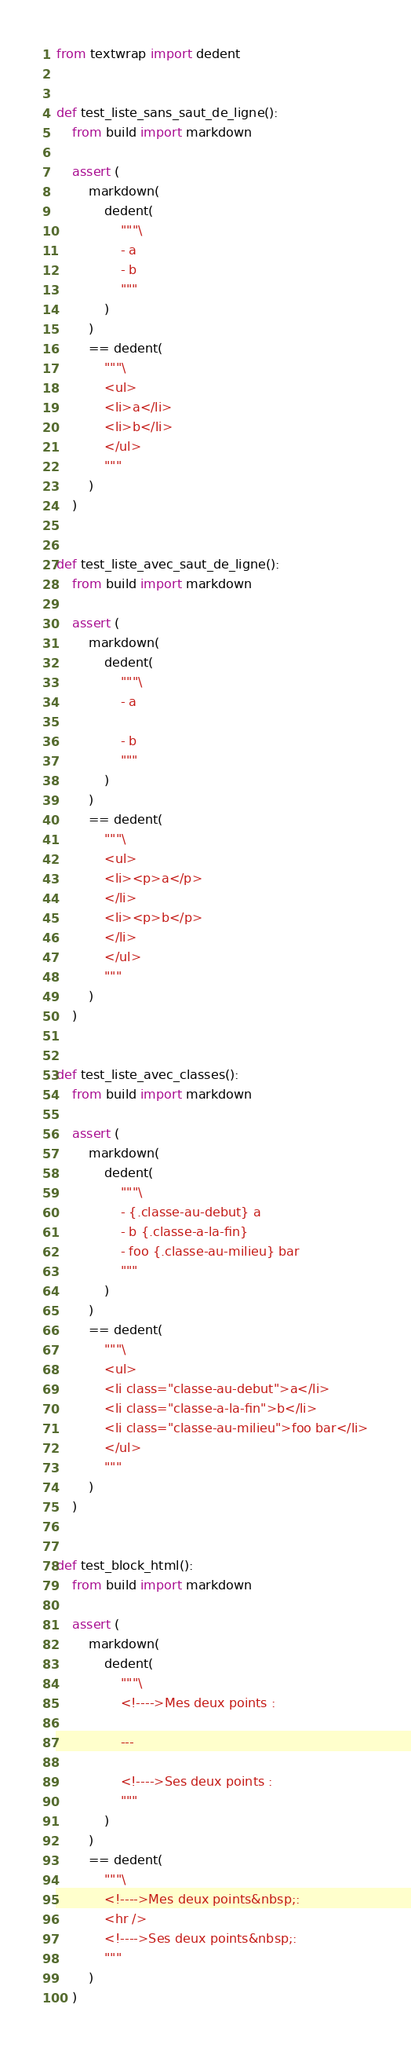<code> <loc_0><loc_0><loc_500><loc_500><_Python_>from textwrap import dedent


def test_liste_sans_saut_de_ligne():
    from build import markdown

    assert (
        markdown(
            dedent(
                """\
                - a
                - b
                """
            )
        )
        == dedent(
            """\
            <ul>
            <li>a</li>
            <li>b</li>
            </ul>
            """
        )
    )


def test_liste_avec_saut_de_ligne():
    from build import markdown

    assert (
        markdown(
            dedent(
                """\
                - a

                - b
                """
            )
        )
        == dedent(
            """\
            <ul>
            <li><p>a</p>
            </li>
            <li><p>b</p>
            </li>
            </ul>
            """
        )
    )


def test_liste_avec_classes():
    from build import markdown

    assert (
        markdown(
            dedent(
                """\
                - {.classe-au-debut} a
                - b {.classe-a-la-fin}
                - foo {.classe-au-milieu} bar
                """
            )
        )
        == dedent(
            """\
            <ul>
            <li class="classe-au-debut">a</li>
            <li class="classe-a-la-fin">b</li>
            <li class="classe-au-milieu">foo bar</li>
            </ul>
            """
        )
    )


def test_block_html():
    from build import markdown

    assert (
        markdown(
            dedent(
                """\
                <!---->Mes deux points :

                ---

                <!---->Ses deux points :
                """
            )
        )
        == dedent(
            """\
            <!---->Mes deux points&nbsp;:
            <hr />
            <!---->Ses deux points&nbsp;:
            """
        )
    )
</code> 